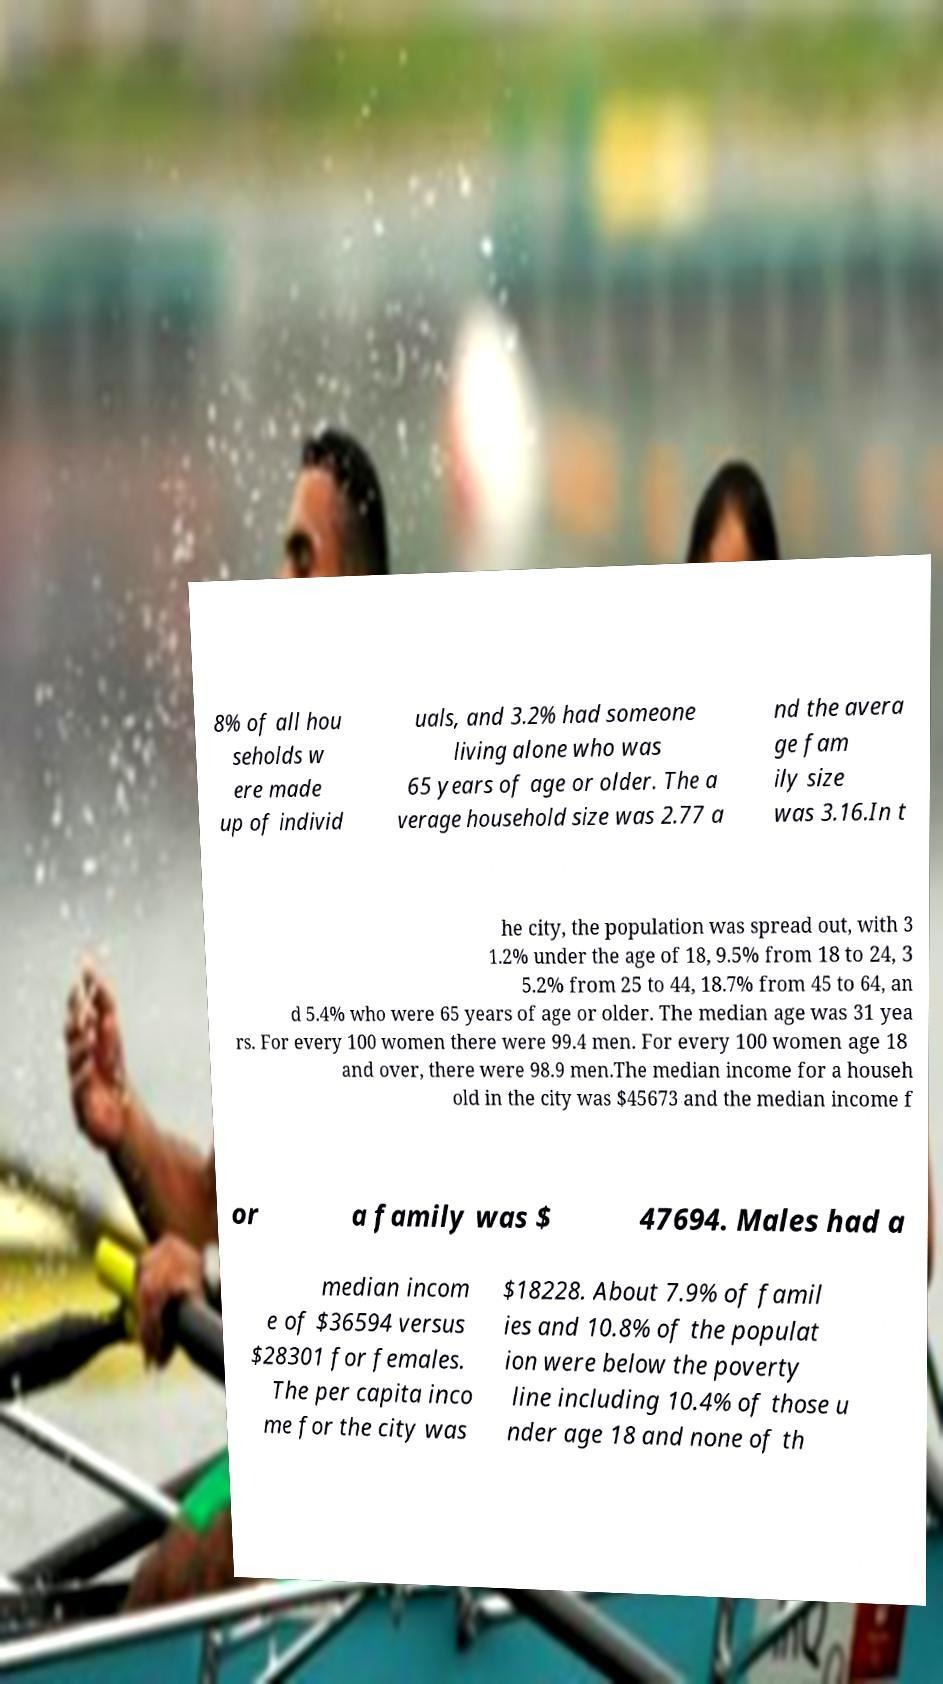I need the written content from this picture converted into text. Can you do that? 8% of all hou seholds w ere made up of individ uals, and 3.2% had someone living alone who was 65 years of age or older. The a verage household size was 2.77 a nd the avera ge fam ily size was 3.16.In t he city, the population was spread out, with 3 1.2% under the age of 18, 9.5% from 18 to 24, 3 5.2% from 25 to 44, 18.7% from 45 to 64, an d 5.4% who were 65 years of age or older. The median age was 31 yea rs. For every 100 women there were 99.4 men. For every 100 women age 18 and over, there were 98.9 men.The median income for a househ old in the city was $45673 and the median income f or a family was $ 47694. Males had a median incom e of $36594 versus $28301 for females. The per capita inco me for the city was $18228. About 7.9% of famil ies and 10.8% of the populat ion were below the poverty line including 10.4% of those u nder age 18 and none of th 